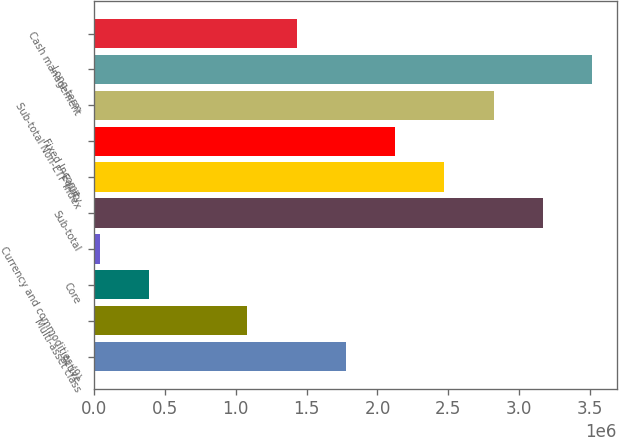<chart> <loc_0><loc_0><loc_500><loc_500><bar_chart><fcel>Active<fcel>Multi-asset class<fcel>Core<fcel>Currency and commodities (9)<fcel>Sub-total<fcel>Equity<fcel>Fixed Income<fcel>Sub-total Non-ETF Index<fcel>Long-term<fcel>Cash management<nl><fcel>1.77699e+06<fcel>1.08272e+06<fcel>388439<fcel>41301<fcel>3.16554e+06<fcel>2.47127e+06<fcel>2.12413e+06<fcel>2.8184e+06<fcel>3.51268e+06<fcel>1.42985e+06<nl></chart> 